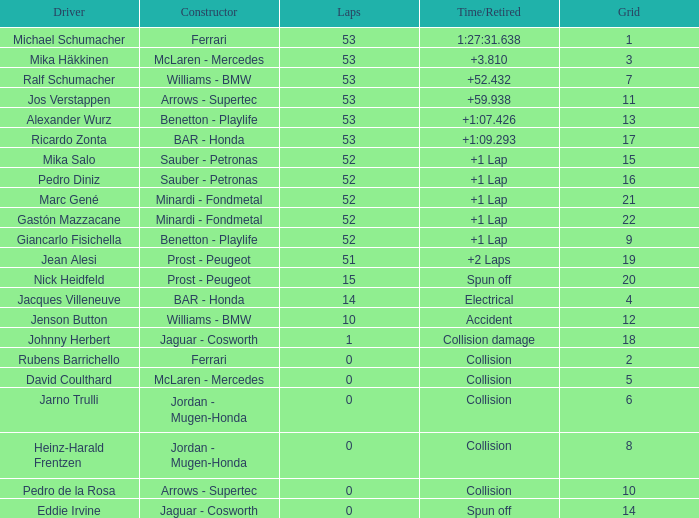What is the average Laps for a grid smaller than 17, and a Constructor of williams - bmw, driven by jenson button? 10.0. 